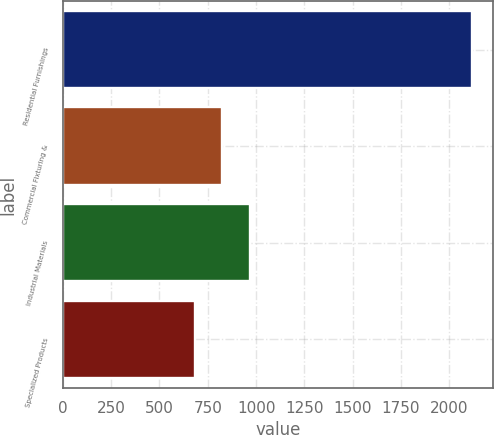Convert chart to OTSL. <chart><loc_0><loc_0><loc_500><loc_500><bar_chart><fcel>Residential Furnishings<fcel>Commercial Fixturing &<fcel>Industrial Materials<fcel>Specialized Products<nl><fcel>2119.8<fcel>825.51<fcel>969.32<fcel>681.7<nl></chart> 